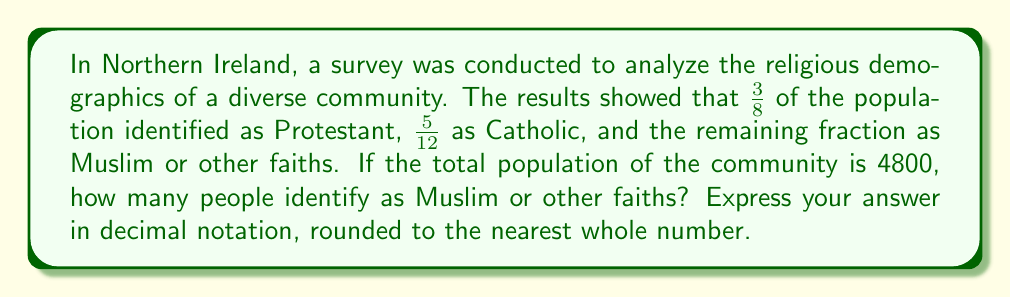Could you help me with this problem? Let's approach this problem step by step:

1) First, we need to find the fraction of the population that identifies as Muslim or other faiths. We can do this by subtracting the fractions of Protestants and Catholics from 1 (the whole):

   $$1 - (\frac{3}{8} + \frac{5}{12}) = 1 - (\frac{9}{24} + \frac{10}{24}) = 1 - \frac{19}{24} = \frac{5}{24}$$

2) Now that we know the fraction of Muslims and other faiths, we can calculate the number of people this represents in a population of 4800:

   $$\frac{5}{24} \times 4800 = \frac{5 \times 4800}{24} = \frac{24000}{24} = 1000$$

3) The question asks for the answer in decimal notation, but 1000 is already a whole number, so no further conversion or rounding is necessary.
Answer: 1000 